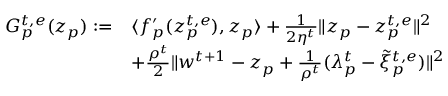Convert formula to latex. <formula><loc_0><loc_0><loc_500><loc_500>\begin{array} { r l } { G _ { p } ^ { t , e } ( z _ { p } ) \colon = } & { \langle f _ { p } ^ { \prime } ( z _ { p } ^ { t , e } ) , z _ { p } \rangle + \frac { 1 } { 2 \eta ^ { t } } \| z _ { p } - z _ { p } ^ { t , e } \| ^ { 2 } } \\ & { + \frac { \rho ^ { t } } { 2 } \| w ^ { t + 1 } - z _ { p } + \frac { 1 } { \rho ^ { t } } ( \lambda _ { p } ^ { t } - \tilde { \xi } _ { p } ^ { t , e } ) \| ^ { 2 } } \end{array}</formula> 